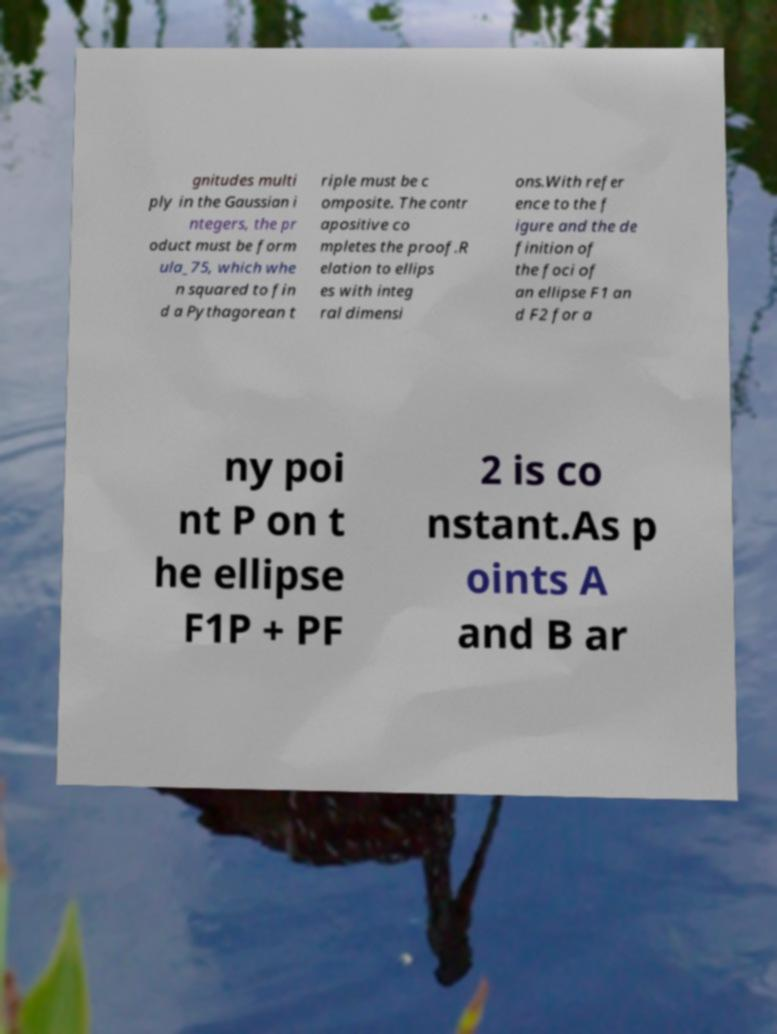Could you assist in decoding the text presented in this image and type it out clearly? gnitudes multi ply in the Gaussian i ntegers, the pr oduct must be form ula_75, which whe n squared to fin d a Pythagorean t riple must be c omposite. The contr apositive co mpletes the proof.R elation to ellips es with integ ral dimensi ons.With refer ence to the f igure and the de finition of the foci of an ellipse F1 an d F2 for a ny poi nt P on t he ellipse F1P + PF 2 is co nstant.As p oints A and B ar 